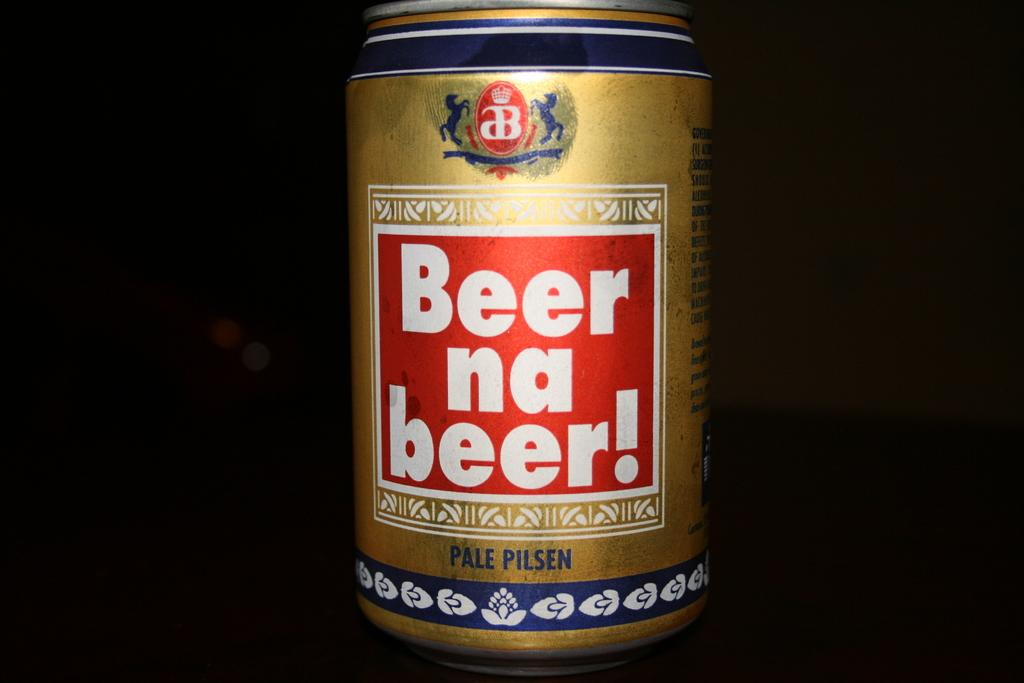<image>
Give a short and clear explanation of the subsequent image. A can of pale pilsen says "beer na beer!" on it. 